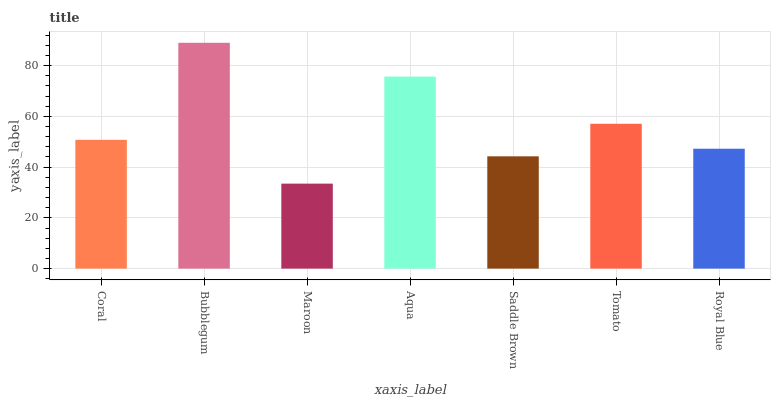Is Maroon the minimum?
Answer yes or no. Yes. Is Bubblegum the maximum?
Answer yes or no. Yes. Is Bubblegum the minimum?
Answer yes or no. No. Is Maroon the maximum?
Answer yes or no. No. Is Bubblegum greater than Maroon?
Answer yes or no. Yes. Is Maroon less than Bubblegum?
Answer yes or no. Yes. Is Maroon greater than Bubblegum?
Answer yes or no. No. Is Bubblegum less than Maroon?
Answer yes or no. No. Is Coral the high median?
Answer yes or no. Yes. Is Coral the low median?
Answer yes or no. Yes. Is Saddle Brown the high median?
Answer yes or no. No. Is Maroon the low median?
Answer yes or no. No. 